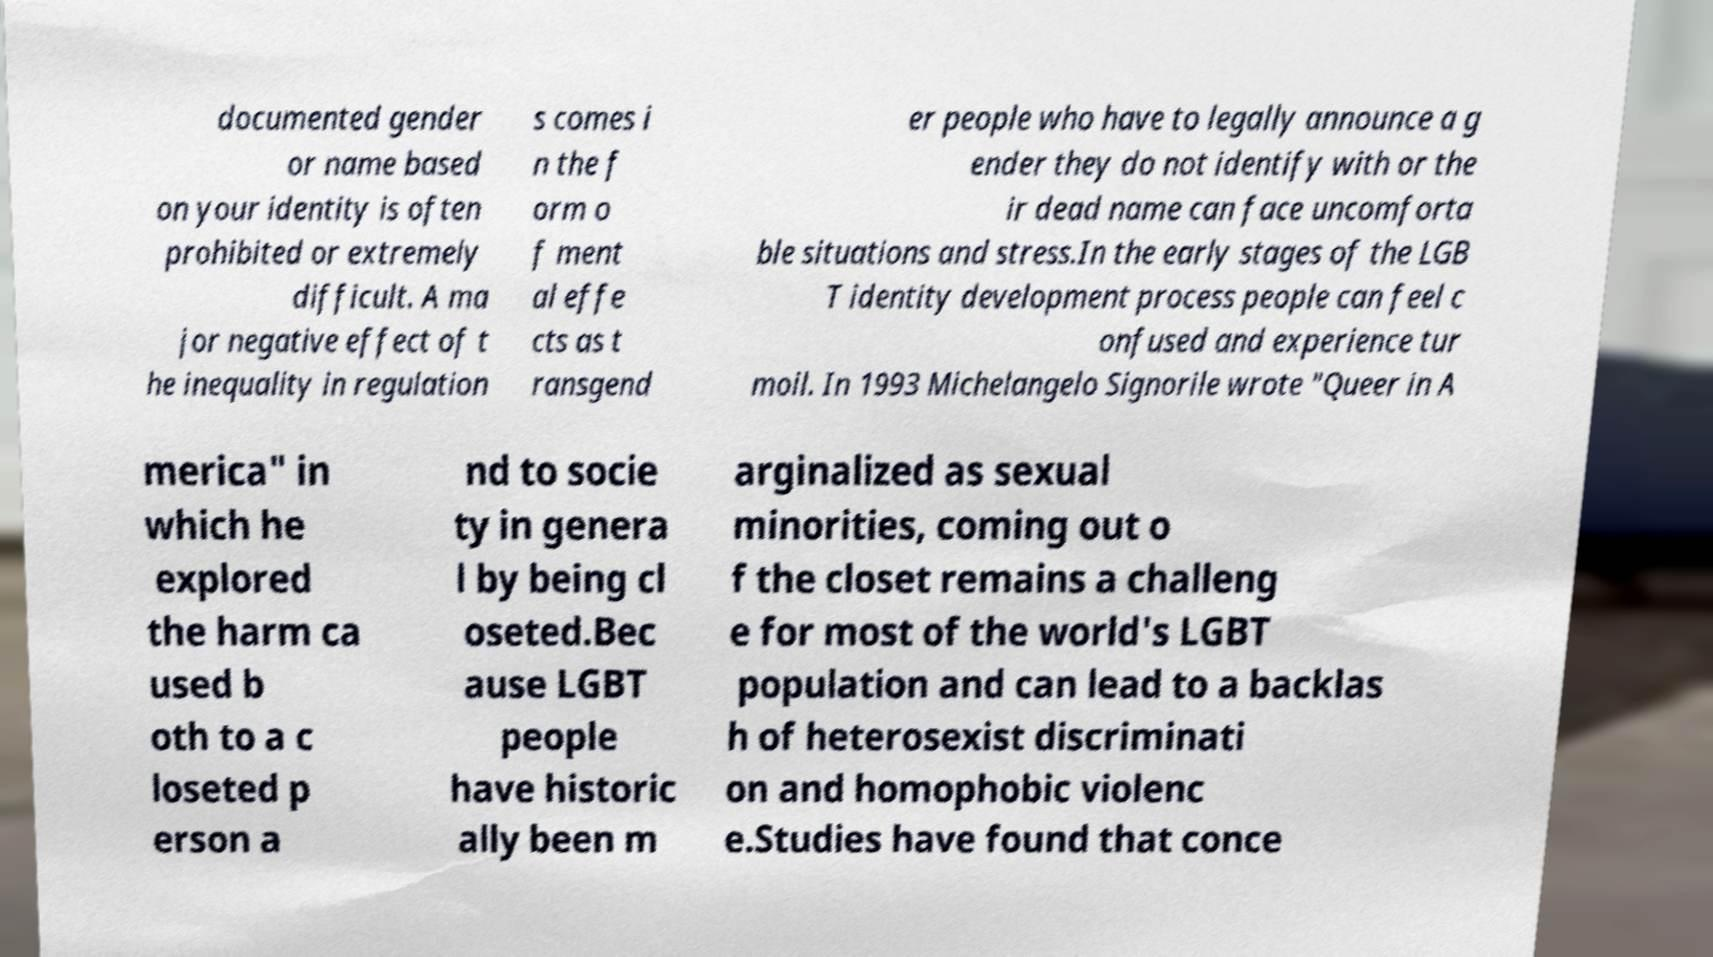Please identify and transcribe the text found in this image. documented gender or name based on your identity is often prohibited or extremely difficult. A ma jor negative effect of t he inequality in regulation s comes i n the f orm o f ment al effe cts as t ransgend er people who have to legally announce a g ender they do not identify with or the ir dead name can face uncomforta ble situations and stress.In the early stages of the LGB T identity development process people can feel c onfused and experience tur moil. In 1993 Michelangelo Signorile wrote "Queer in A merica" in which he explored the harm ca used b oth to a c loseted p erson a nd to socie ty in genera l by being cl oseted.Bec ause LGBT people have historic ally been m arginalized as sexual minorities, coming out o f the closet remains a challeng e for most of the world's LGBT population and can lead to a backlas h of heterosexist discriminati on and homophobic violenc e.Studies have found that conce 